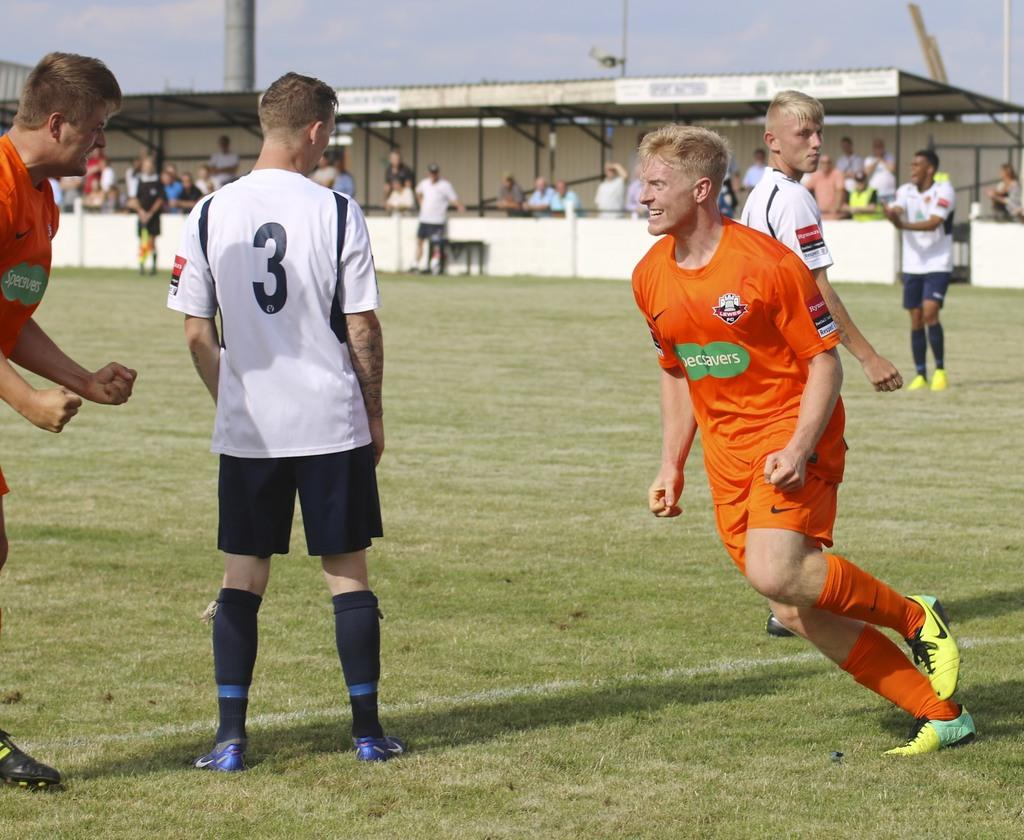<image>
Share a concise interpretation of the image provided. Player number 3 stands still as a player in an orange shirt runs by him. 